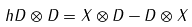Convert formula to latex. <formula><loc_0><loc_0><loc_500><loc_500>h D \otimes D = X \otimes D - D \otimes X</formula> 